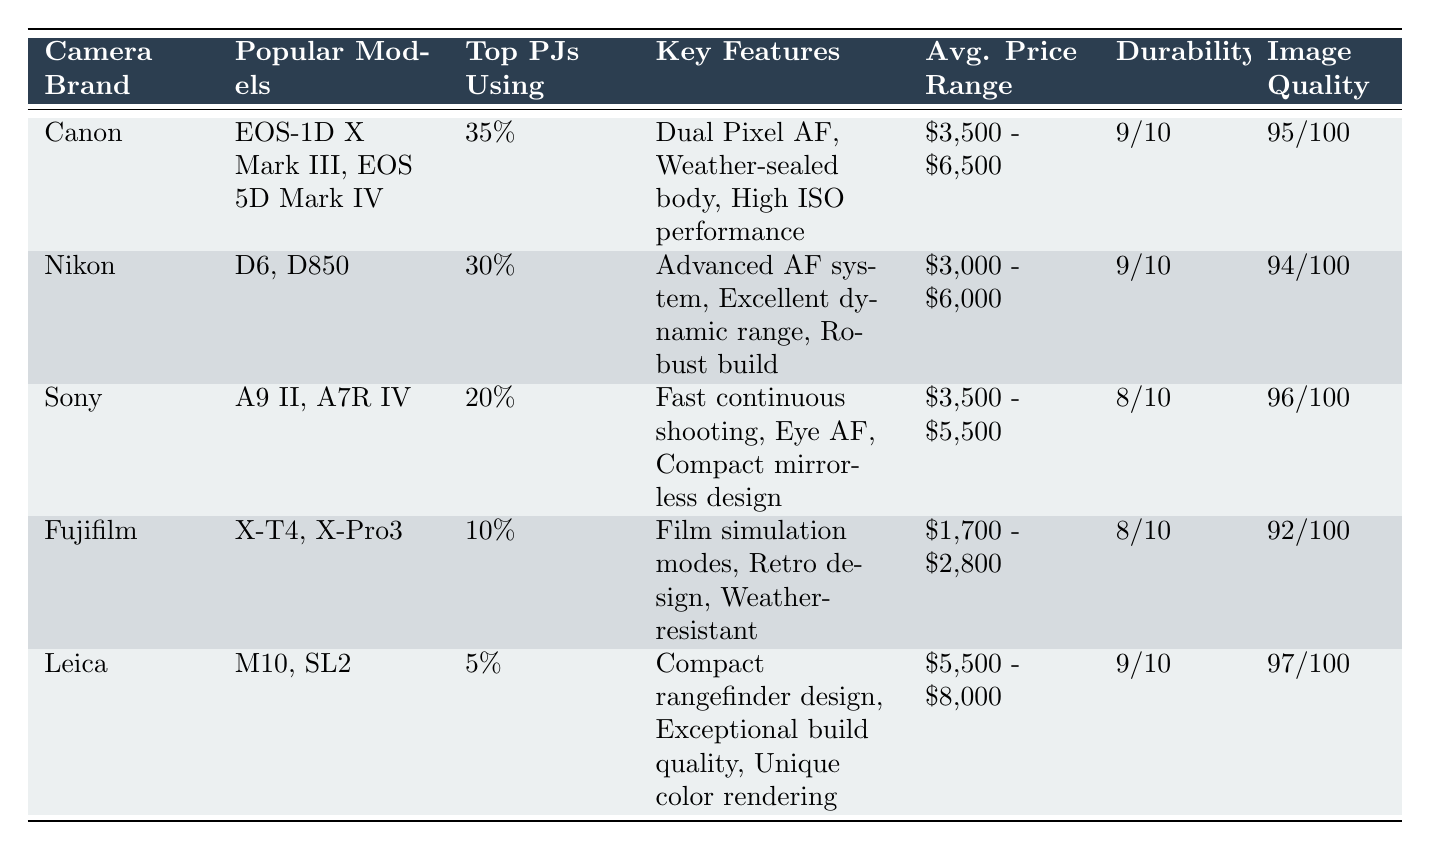What percentage of top photojournalists use Canon cameras? According to the table, Canon has "35%" listed under the "Percentage of Top Photojournalists Using" column.
Answer: 35% Which camera brand has the highest image quality score? The "Image Quality Score" column shows that Leica has the highest score at "97/100."
Answer: Leica What is the average price range of Fujifilm cameras? The average price range for Fujifilm cameras specified in the table is "$1,700 - $2,800."
Answer: $1,700 - $2,800 What is the percentage difference between the top photojournalists using Canon and those using Nikon? Canon has 35% and Nikon has 30%. The difference is calculated as 35% - 30% = 5%.
Answer: 5% Is it true that Sony has a better durability rating than Fujifilm? Looking at the "Durability Rating" column, Sony has a rating of "8/10" while Fujifilm also has "8/10," so the statement is false since they are equal.
Answer: No Which camera brand's popular models are the EOS-1D X Mark III and EOS 5D Mark IV? The table indicates that these models belong to Canon, listed under the "Popular Models" column.
Answer: Canon If we average the image quality scores of Canon, Nikon, and Sony, what would that be? Canon has an image quality score of 95, Nikon 94, and Sony 96. (95 + 94 + 96) / 3 = 95.
Answer: 95 What key features are highlighted for Nikon cameras? The table states Nikon's key features as "Advanced AF system, Excellent dynamic range, Robust build."
Answer: Advanced AF system, Excellent dynamic range, Robust build How many camera brands have a durability rating of at least 9 out of 10? From the table, both Canon and Leica have a durability rating of "9/10," which means there are two brands that qualify.
Answer: 2 